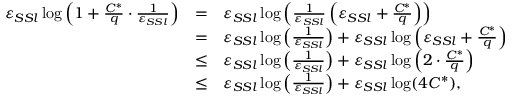<formula> <loc_0><loc_0><loc_500><loc_500>\begin{array} { r c l } { \varepsilon _ { S S l } \log \left ( 1 + \frac { C ^ { * } } { q } \cdot \frac { 1 } { \varepsilon _ { S S l } } \right ) } & { = } & { \varepsilon _ { S S l } \log \left ( \frac { 1 } { \varepsilon _ { S S l } } \left ( \varepsilon _ { S S l } + \frac { C ^ { * } } { q } \right ) \right ) } \\ & { = } & { \varepsilon _ { S S l } \log \left ( \frac { 1 } { \varepsilon _ { S S l } } \right ) + \varepsilon _ { S S l } \log \left ( \varepsilon _ { S S l } + \frac { C ^ { * } } { q } \right ) } \\ & { \leq } & { \varepsilon _ { S S l } \log \left ( \frac { 1 } { \varepsilon _ { S S l } } \right ) + \varepsilon _ { S S l } \log \left ( 2 \cdot \frac { C ^ { * } } { q } \right ) } \\ & { \leq } & { \varepsilon _ { S S l } \log \left ( \frac { 1 } { \varepsilon _ { S S l } } \right ) + \varepsilon _ { S S l } \log ( 4 C ^ { * } ) , } \end{array}</formula> 